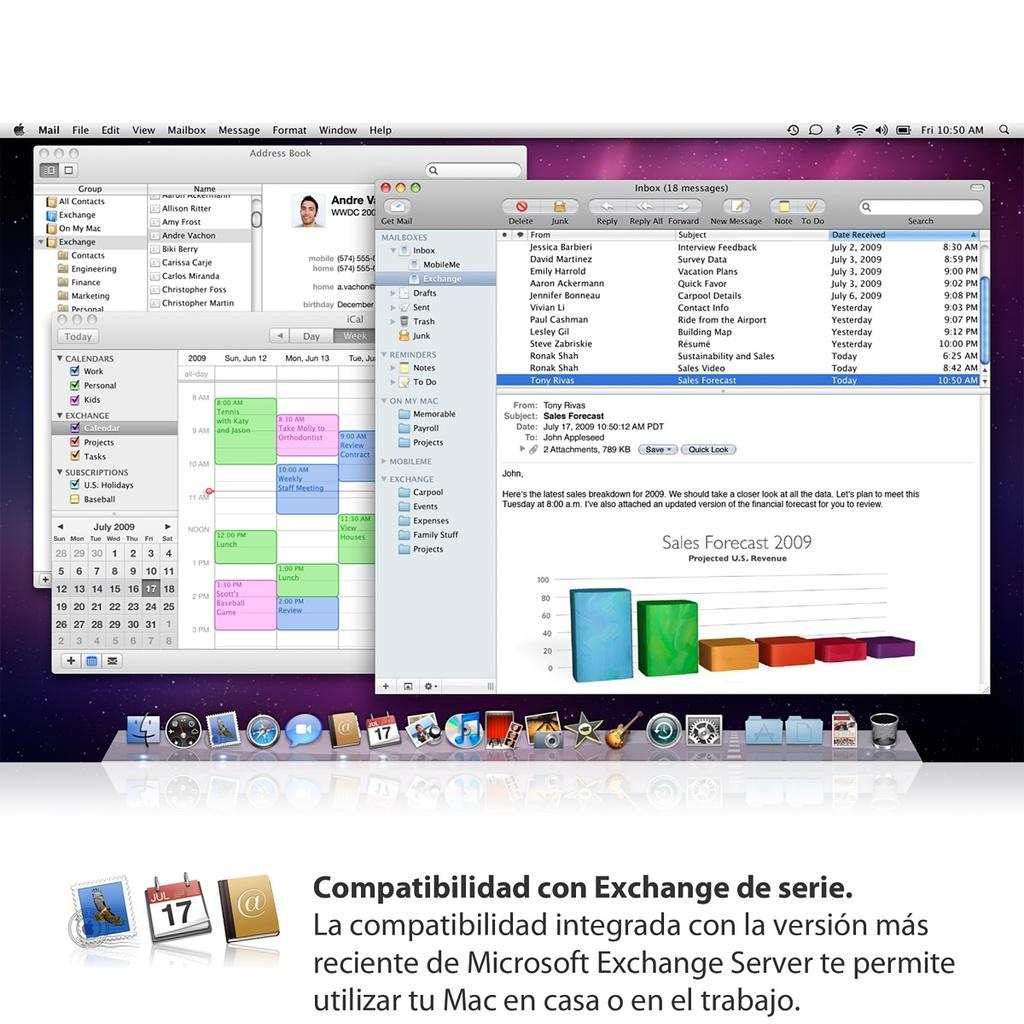What year is the program from?
Your response must be concise. 2009. What number is written in the calendar icon?
Offer a very short reply. 17. 